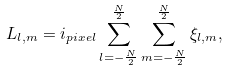Convert formula to latex. <formula><loc_0><loc_0><loc_500><loc_500>L _ { l , m } = i _ { p i x e l } \sum _ { l = - \frac { N } { 2 } } ^ { \frac { N } { 2 } } \sum _ { m = - \frac { N } { 2 } } ^ { \frac { N } { 2 } } \xi _ { l , m } ,</formula> 